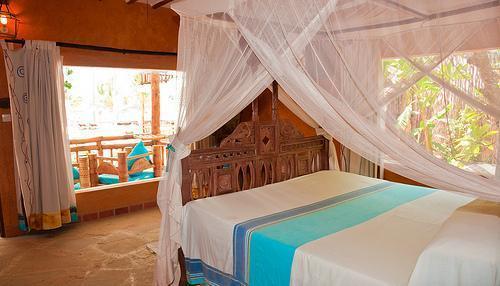How many beds are there?
Give a very brief answer. 1. 